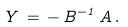<formula> <loc_0><loc_0><loc_500><loc_500>Y \, = \, - \, B ^ { - 1 } \, A \, .</formula> 